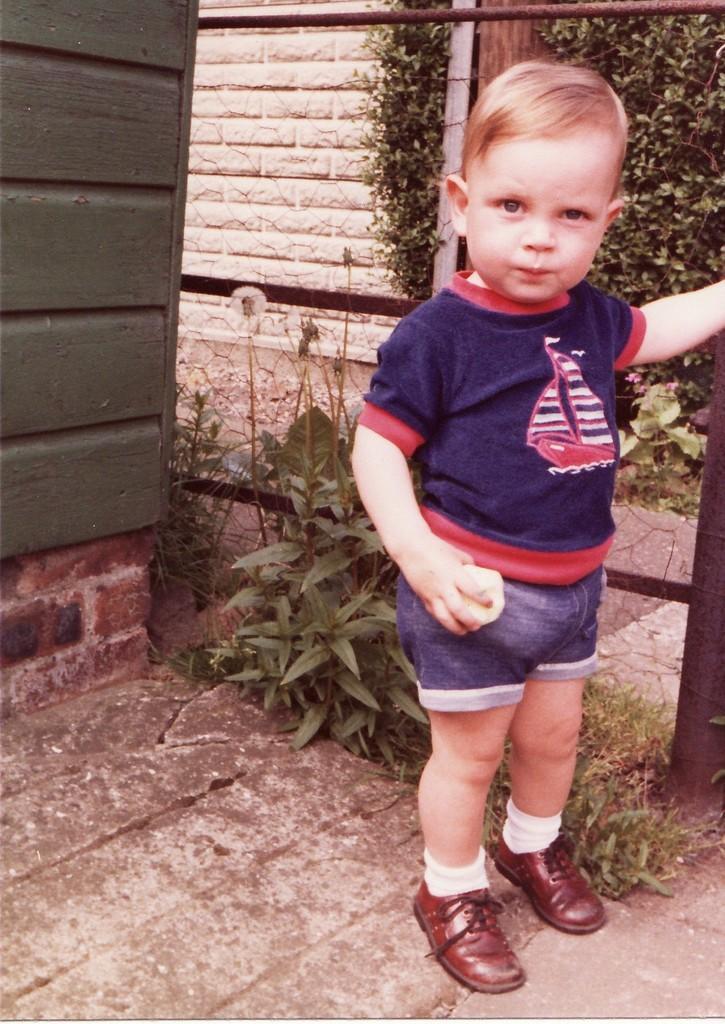Describe this image in one or two sentences. In the image we can a child standing, wearing clothes, socks and shoes. Here we can see the grass, plant and the wall. 